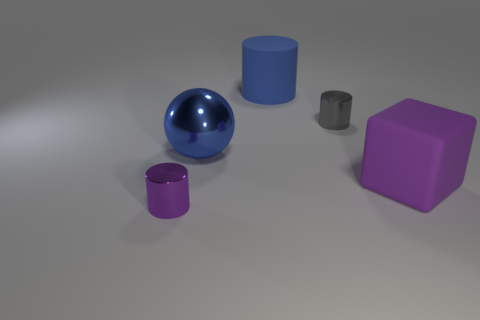Is there a metallic cylinder to the right of the large blue object in front of the tiny object that is on the right side of the small purple thing?
Ensure brevity in your answer.  Yes. Are there any other things that are the same size as the purple matte thing?
Your response must be concise. Yes. Do the gray metal thing and the blue thing behind the tiny gray metallic cylinder have the same shape?
Offer a terse response. Yes. What is the color of the rubber thing that is on the right side of the rubber object behind the metal object that is to the right of the big blue cylinder?
Offer a terse response. Purple. How many things are either shiny cylinders on the right side of the tiny purple object or large blue objects that are right of the big metal thing?
Keep it short and to the point. 2. How many other objects are the same color as the big shiny thing?
Offer a terse response. 1. Do the purple object that is left of the purple block and the blue rubber thing have the same shape?
Your answer should be compact. Yes. Is the number of big matte objects that are on the left side of the rubber cylinder less than the number of small gray metallic cylinders?
Provide a succinct answer. Yes. Are there any other big green blocks that have the same material as the block?
Make the answer very short. No. What material is the purple cylinder that is the same size as the gray object?
Your response must be concise. Metal. 